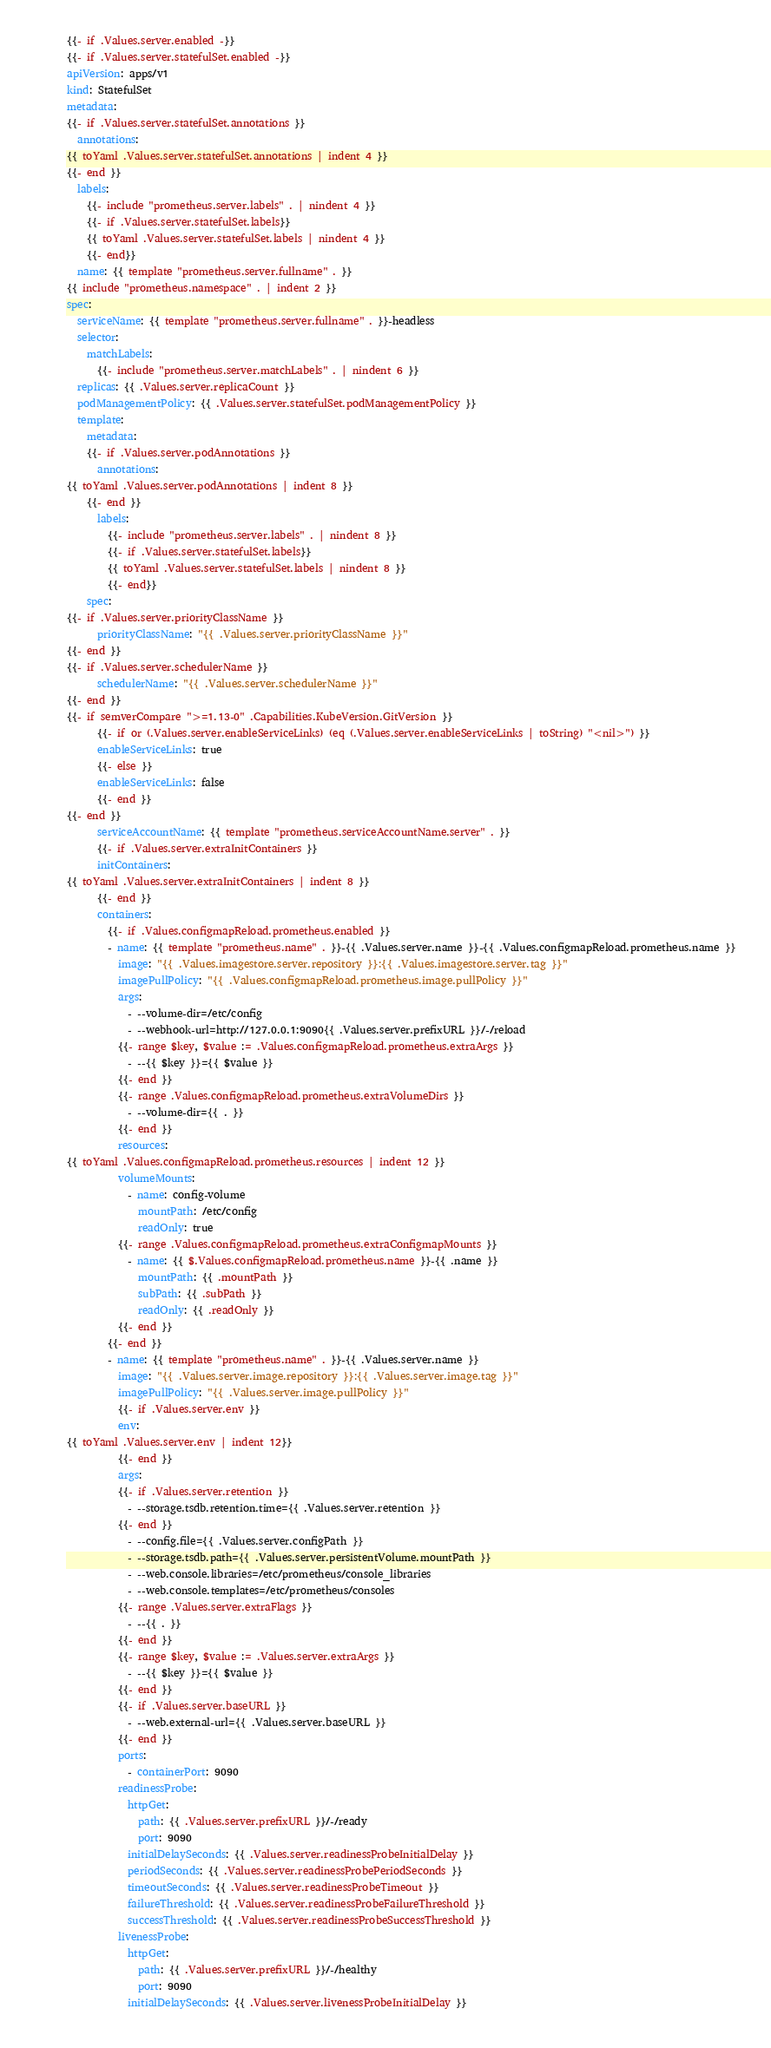<code> <loc_0><loc_0><loc_500><loc_500><_YAML_>{{- if .Values.server.enabled -}}
{{- if .Values.server.statefulSet.enabled -}}
apiVersion: apps/v1
kind: StatefulSet
metadata:
{{- if .Values.server.statefulSet.annotations }}
  annotations:
{{ toYaml .Values.server.statefulSet.annotations | indent 4 }}
{{- end }}
  labels:
    {{- include "prometheus.server.labels" . | nindent 4 }}
    {{- if .Values.server.statefulSet.labels}}
    {{ toYaml .Values.server.statefulSet.labels | nindent 4 }}
    {{- end}}
  name: {{ template "prometheus.server.fullname" . }}
{{ include "prometheus.namespace" . | indent 2 }}
spec:
  serviceName: {{ template "prometheus.server.fullname" . }}-headless
  selector:
    matchLabels:
      {{- include "prometheus.server.matchLabels" . | nindent 6 }}
  replicas: {{ .Values.server.replicaCount }}
  podManagementPolicy: {{ .Values.server.statefulSet.podManagementPolicy }}
  template:
    metadata:
    {{- if .Values.server.podAnnotations }}
      annotations:
{{ toYaml .Values.server.podAnnotations | indent 8 }}
    {{- end }}
      labels:
        {{- include "prometheus.server.labels" . | nindent 8 }}
        {{- if .Values.server.statefulSet.labels}}
        {{ toYaml .Values.server.statefulSet.labels | nindent 8 }}
        {{- end}}
    spec:
{{- if .Values.server.priorityClassName }}
      priorityClassName: "{{ .Values.server.priorityClassName }}"
{{- end }}
{{- if .Values.server.schedulerName }}
      schedulerName: "{{ .Values.server.schedulerName }}"
{{- end }}
{{- if semverCompare ">=1.13-0" .Capabilities.KubeVersion.GitVersion }}
      {{- if or (.Values.server.enableServiceLinks) (eq (.Values.server.enableServiceLinks | toString) "<nil>") }}
      enableServiceLinks: true
      {{- else }}
      enableServiceLinks: false
      {{- end }}
{{- end }}
      serviceAccountName: {{ template "prometheus.serviceAccountName.server" . }}
      {{- if .Values.server.extraInitContainers }}
      initContainers:
{{ toYaml .Values.server.extraInitContainers | indent 8 }}
      {{- end }}
      containers:
        {{- if .Values.configmapReload.prometheus.enabled }}
        - name: {{ template "prometheus.name" . }}-{{ .Values.server.name }}-{{ .Values.configmapReload.prometheus.name }}
          image: "{{ .Values.imagestore.server.repository }}:{{ .Values.imagestore.server.tag }}"
          imagePullPolicy: "{{ .Values.configmapReload.prometheus.image.pullPolicy }}"
          args:
            - --volume-dir=/etc/config
            - --webhook-url=http://127.0.0.1:9090{{ .Values.server.prefixURL }}/-/reload
          {{- range $key, $value := .Values.configmapReload.prometheus.extraArgs }}
            - --{{ $key }}={{ $value }}
          {{- end }}
          {{- range .Values.configmapReload.prometheus.extraVolumeDirs }}
            - --volume-dir={{ . }}
          {{- end }}
          resources:
{{ toYaml .Values.configmapReload.prometheus.resources | indent 12 }}
          volumeMounts:
            - name: config-volume
              mountPath: /etc/config
              readOnly: true
          {{- range .Values.configmapReload.prometheus.extraConfigmapMounts }}
            - name: {{ $.Values.configmapReload.prometheus.name }}-{{ .name }}
              mountPath: {{ .mountPath }}
              subPath: {{ .subPath }}
              readOnly: {{ .readOnly }}
          {{- end }}
        {{- end }}
        - name: {{ template "prometheus.name" . }}-{{ .Values.server.name }}
          image: "{{ .Values.server.image.repository }}:{{ .Values.server.image.tag }}"
          imagePullPolicy: "{{ .Values.server.image.pullPolicy }}"
          {{- if .Values.server.env }}
          env:
{{ toYaml .Values.server.env | indent 12}}
          {{- end }}
          args:
          {{- if .Values.server.retention }}
            - --storage.tsdb.retention.time={{ .Values.server.retention }}
          {{- end }}
            - --config.file={{ .Values.server.configPath }}
            - --storage.tsdb.path={{ .Values.server.persistentVolume.mountPath }}
            - --web.console.libraries=/etc/prometheus/console_libraries
            - --web.console.templates=/etc/prometheus/consoles
          {{- range .Values.server.extraFlags }}
            - --{{ . }}
          {{- end }}
          {{- range $key, $value := .Values.server.extraArgs }}
            - --{{ $key }}={{ $value }}
          {{- end }}
          {{- if .Values.server.baseURL }}
            - --web.external-url={{ .Values.server.baseURL }}
          {{- end }}
          ports:
            - containerPort: 9090
          readinessProbe:
            httpGet:
              path: {{ .Values.server.prefixURL }}/-/ready
              port: 9090
            initialDelaySeconds: {{ .Values.server.readinessProbeInitialDelay }}
            periodSeconds: {{ .Values.server.readinessProbePeriodSeconds }}
            timeoutSeconds: {{ .Values.server.readinessProbeTimeout }}
            failureThreshold: {{ .Values.server.readinessProbeFailureThreshold }}
            successThreshold: {{ .Values.server.readinessProbeSuccessThreshold }}
          livenessProbe:
            httpGet:
              path: {{ .Values.server.prefixURL }}/-/healthy
              port: 9090
            initialDelaySeconds: {{ .Values.server.livenessProbeInitialDelay }}</code> 